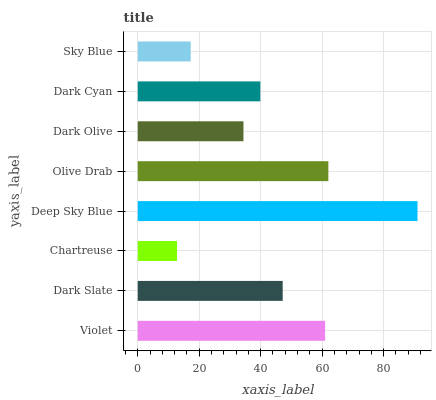Is Chartreuse the minimum?
Answer yes or no. Yes. Is Deep Sky Blue the maximum?
Answer yes or no. Yes. Is Dark Slate the minimum?
Answer yes or no. No. Is Dark Slate the maximum?
Answer yes or no. No. Is Violet greater than Dark Slate?
Answer yes or no. Yes. Is Dark Slate less than Violet?
Answer yes or no. Yes. Is Dark Slate greater than Violet?
Answer yes or no. No. Is Violet less than Dark Slate?
Answer yes or no. No. Is Dark Slate the high median?
Answer yes or no. Yes. Is Dark Cyan the low median?
Answer yes or no. Yes. Is Violet the high median?
Answer yes or no. No. Is Deep Sky Blue the low median?
Answer yes or no. No. 